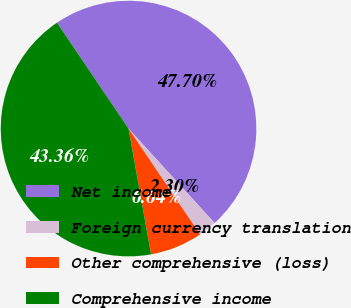Convert chart to OTSL. <chart><loc_0><loc_0><loc_500><loc_500><pie_chart><fcel>Net income<fcel>Foreign currency translation<fcel>Other comprehensive (loss)<fcel>Comprehensive income<nl><fcel>47.7%<fcel>2.3%<fcel>6.64%<fcel>43.36%<nl></chart> 